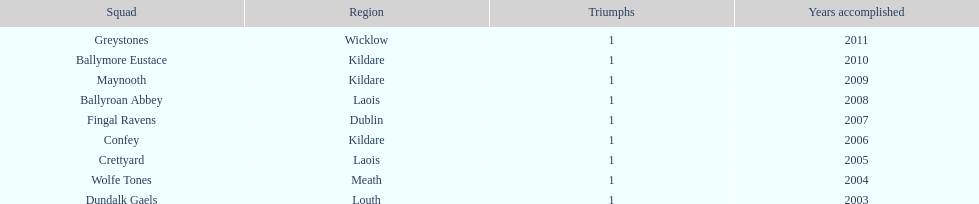Parse the full table. {'header': ['Squad', 'Region', 'Triumphs', 'Years accomplished'], 'rows': [['Greystones', 'Wicklow', '1', '2011'], ['Ballymore Eustace', 'Kildare', '1', '2010'], ['Maynooth', 'Kildare', '1', '2009'], ['Ballyroan Abbey', 'Laois', '1', '2008'], ['Fingal Ravens', 'Dublin', '1', '2007'], ['Confey', 'Kildare', '1', '2006'], ['Crettyard', 'Laois', '1', '2005'], ['Wolfe Tones', 'Meath', '1', '2004'], ['Dundalk Gaels', 'Louth', '1', '2003']]} What is the total of wins on the chart 9. 